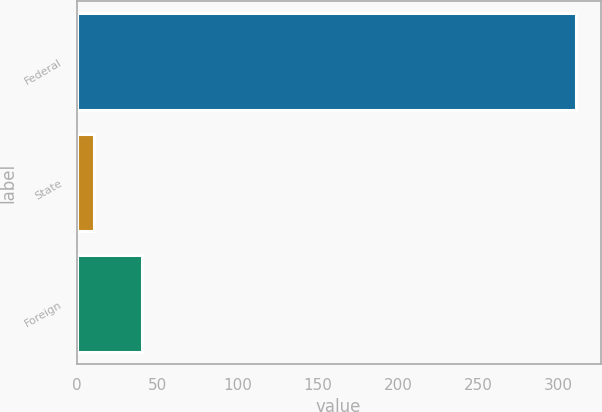Convert chart. <chart><loc_0><loc_0><loc_500><loc_500><bar_chart><fcel>Federal<fcel>State<fcel>Foreign<nl><fcel>310.6<fcel>10.9<fcel>40.87<nl></chart> 